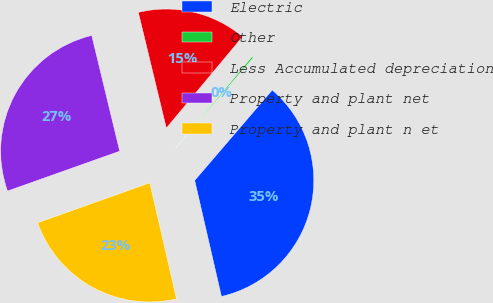Convert chart. <chart><loc_0><loc_0><loc_500><loc_500><pie_chart><fcel>Electric<fcel>Other<fcel>Less Accumulated depreciation<fcel>Property and plant net<fcel>Property and plant n et<nl><fcel>35.11%<fcel>0.22%<fcel>14.84%<fcel>26.66%<fcel>23.17%<nl></chart> 